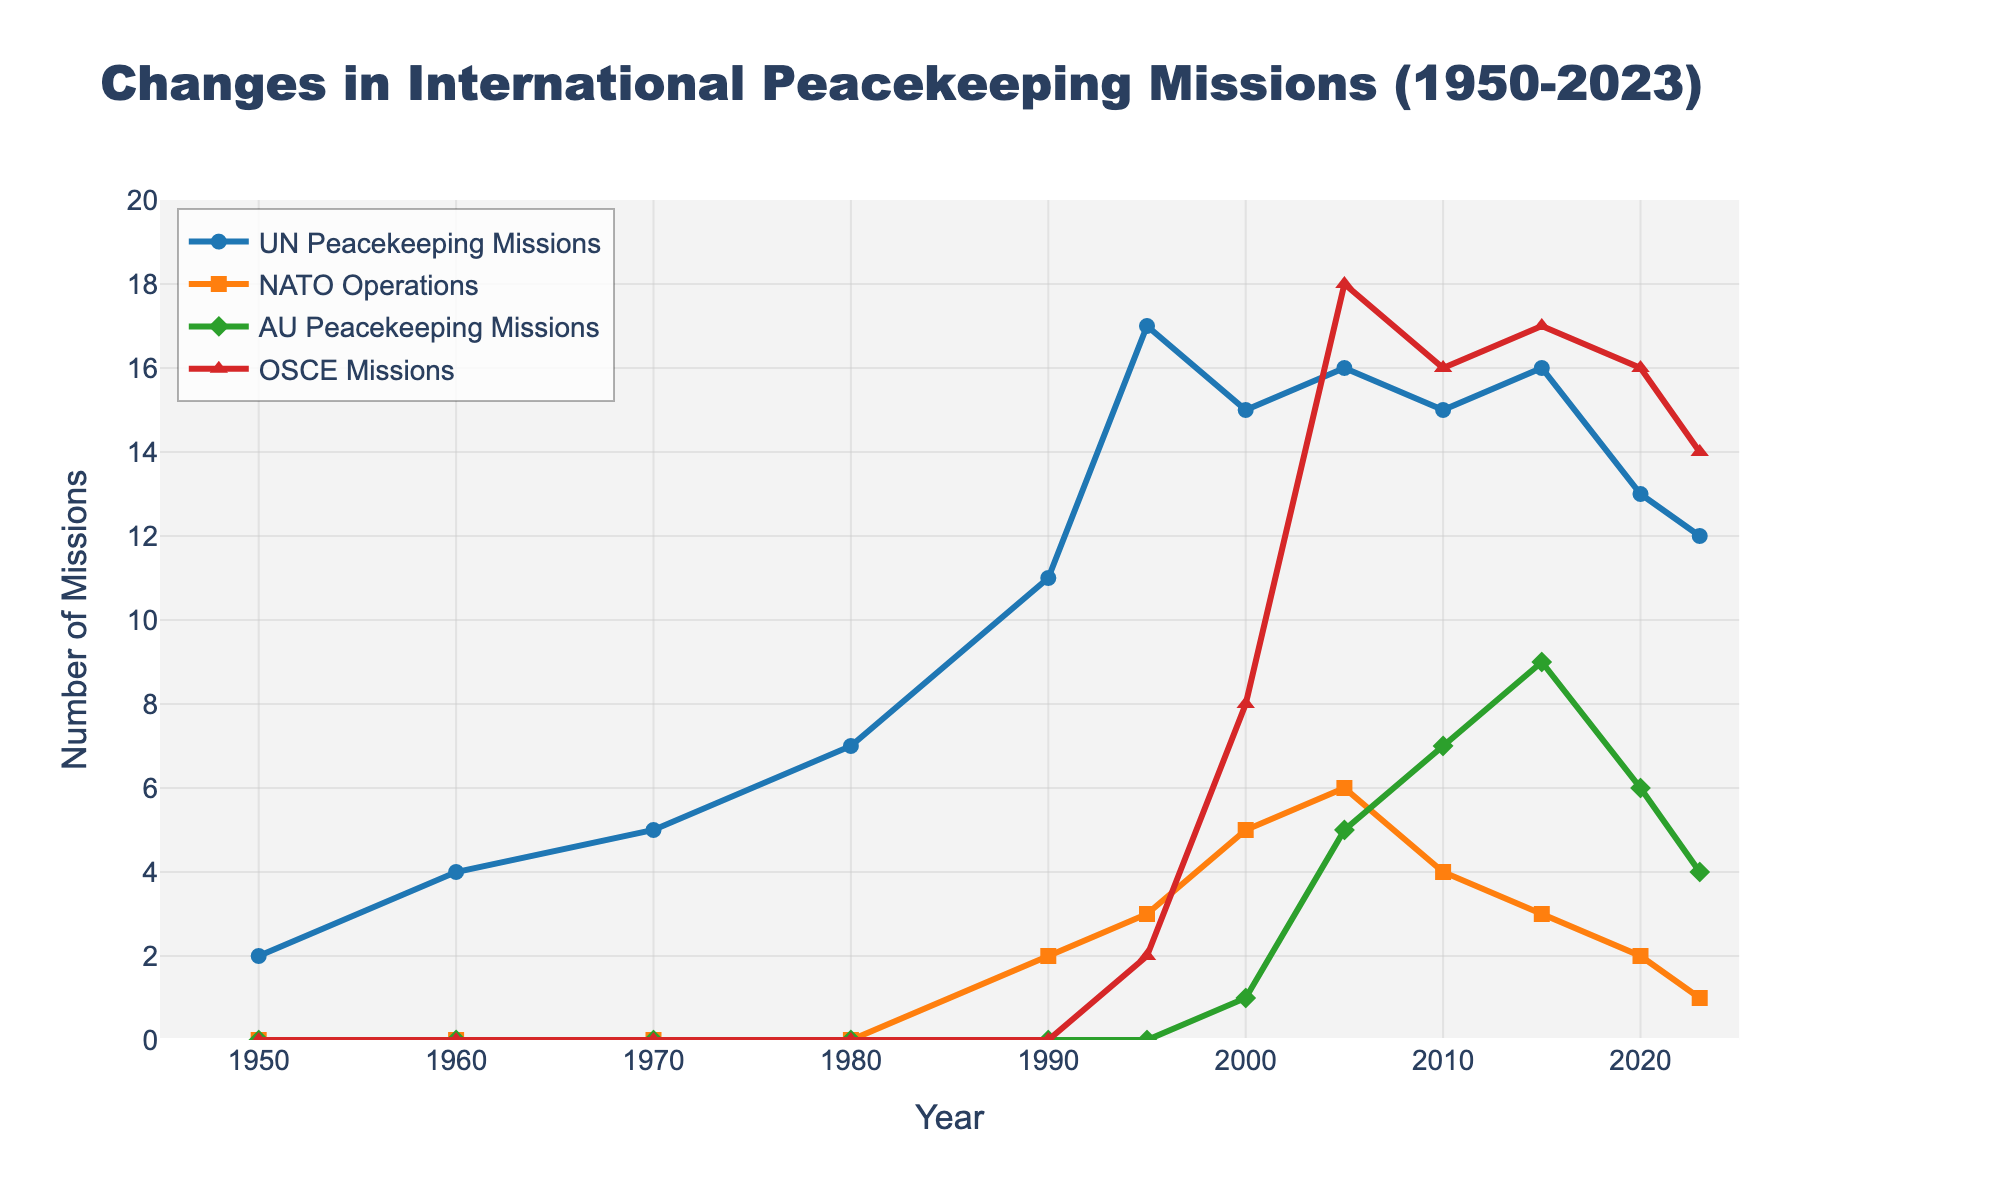What type of missions peaked in the year 2005? To answer this, observe the lines on the chart at the year 2005. Identify the highest values among the different types of missions. The UN Peacekeeping Missions, NATO Operations, and OSCE Missions all show their respective peaks at this year.
Answer: UN Peacekeeping Missions, NATO Operations, OSCE Missions How many UN Peacekeeping Missions were there in 1980 compared to 1995? Look at the points corresponding to UN Peacekeeping Missions for the years 1980 and 1995. In 1980, there are 7 missions and in 1995, there are 17 missions. Subtract the former from the latter to get the difference.
Answer: 10 more missions in 1995 Which type of mission had the most gradual increase from 1990 to 2023? Observe the slopes of the lines for each type of mission between 1990 and 2023. The line for AU Peacekeeping Missions shows a steady, gradual increase over this period.
Answer: AU Peacekeeping Missions What was the increase in the number of AU Peacekeeping Missions between 2000 and 2010? Look at the data points for AU Peacekeeping Missions in 2000 and 2010. In 2000, there is 1 mission, and in 2010, there are 7 missions. Calculate the difference.
Answer: Increased by 6 missions Which years show a peak in OSCE Missions? Observe the line representing OSCE Missions and note the years where the line reaches the highest points. The peaks are in 2005 and 2015.
Answer: 2005, 2015 What is the trend for NATO Operations from 2000 to 2023? Track the points for NATO Operations from 2000 to 2023. Initially, there is a rise from 5 to 6 in 2005, followed by a gradual decline to 1 in 2023.
Answer: Rise and then decline Which type of mission had the maximum value in any given year? Observe the highest peak across all missions on the chart. Count the number of missions at that point. The UN Peacekeeping Missions reach a maximum value of 17 in 1995.
Answer: UN Peacekeeping Missions Compare the number of OSCE Missions and AU Peacekeeping Missions in 2023. Look at the points for both OSCE Missions and AU Peacekeeping Missions in 2023. OSCE Missions are 14, and AU Peacekeeping Missions are 4.
Answer: OSCE Missions are higher by 10 